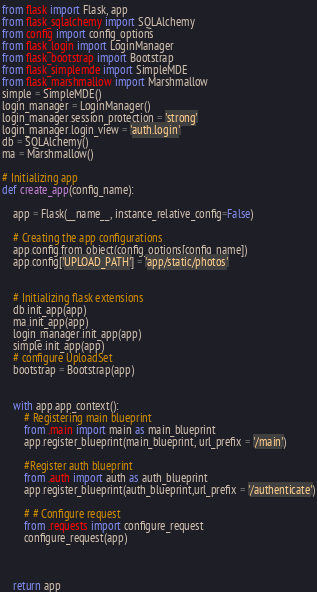Convert code to text. <code><loc_0><loc_0><loc_500><loc_500><_Python_>from flask import Flask, app
from flask_sqlalchemy import SQLAlchemy
from config import config_options
from flask_login import LoginManager
from flask_bootstrap import Bootstrap
from flask_simplemde import SimpleMDE
from flask_marshmallow import Marshmallow
simple = SimpleMDE()
login_manager = LoginManager()
login_manager.session_protection = 'strong'
login_manager.login_view = 'auth.login'
db = SQLAlchemy()
ma = Marshmallow()

# Initializing app
def create_app(config_name):

    app = Flask(__name__, instance_relative_config=False)

    # Creating the app configurations
    app.config.from_object(config_options[config_name])
    app.config['UPLOAD_PATH'] = 'app/static/photos'
   

    # Initializing flask extensions
    db.init_app(app)
    ma.init_app(app)
    login_manager.init_app(app)
    simple.init_app(app)
    # configure UploadSet
    bootstrap = Bootstrap(app)
    

    with app.app_context():
        # Registering main blueprint
        from .main import main as main_blueprint
        app.register_blueprint(main_blueprint, url_prefix = '/main')

        #Register auth blueprint
        from .auth import auth as auth_blueprint
        app.register_blueprint(auth_blueprint,url_prefix = '/authenticate')
    
        # # Configure request   
        from .requests import configure_request
        configure_request(app)
      
   
   
    return app</code> 